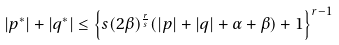<formula> <loc_0><loc_0><loc_500><loc_500>| p ^ { * } | + | q ^ { * } | \leq \left \{ s ( 2 \beta ) ^ { \frac { r } { s } } ( | p | + | q | + \alpha + \beta ) + 1 \right \} ^ { r - 1 }</formula> 